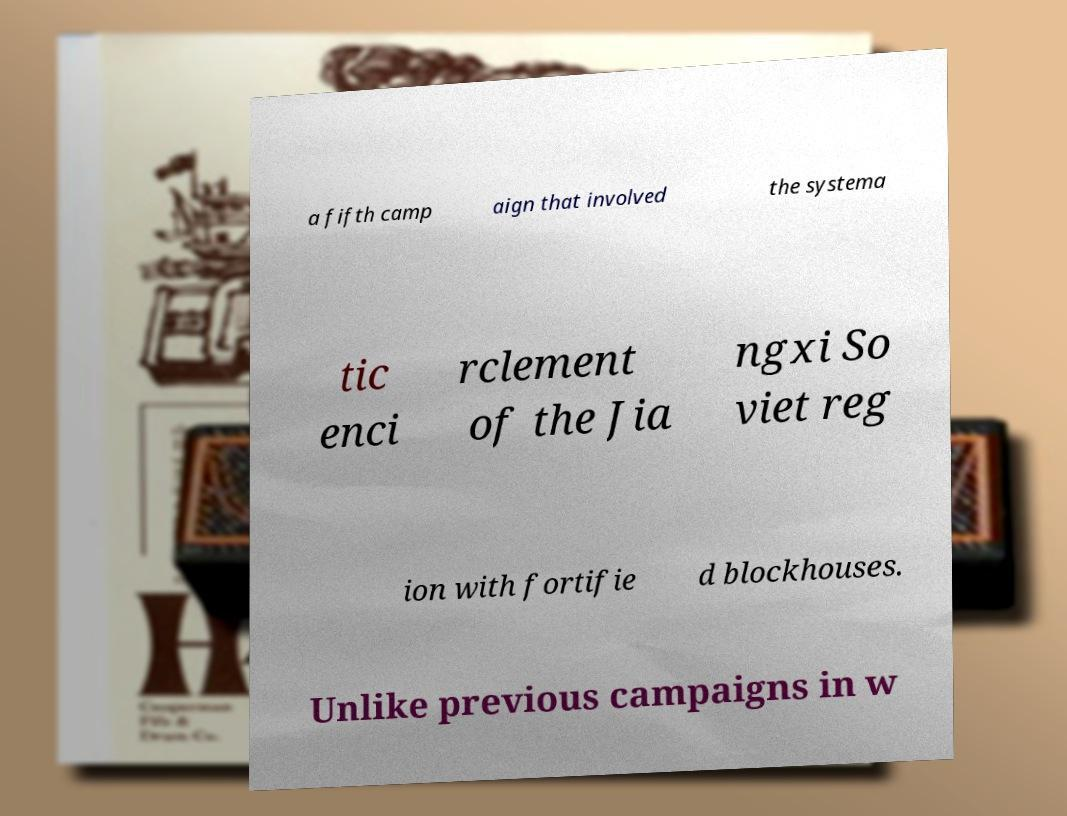Can you read and provide the text displayed in the image?This photo seems to have some interesting text. Can you extract and type it out for me? a fifth camp aign that involved the systema tic enci rclement of the Jia ngxi So viet reg ion with fortifie d blockhouses. Unlike previous campaigns in w 